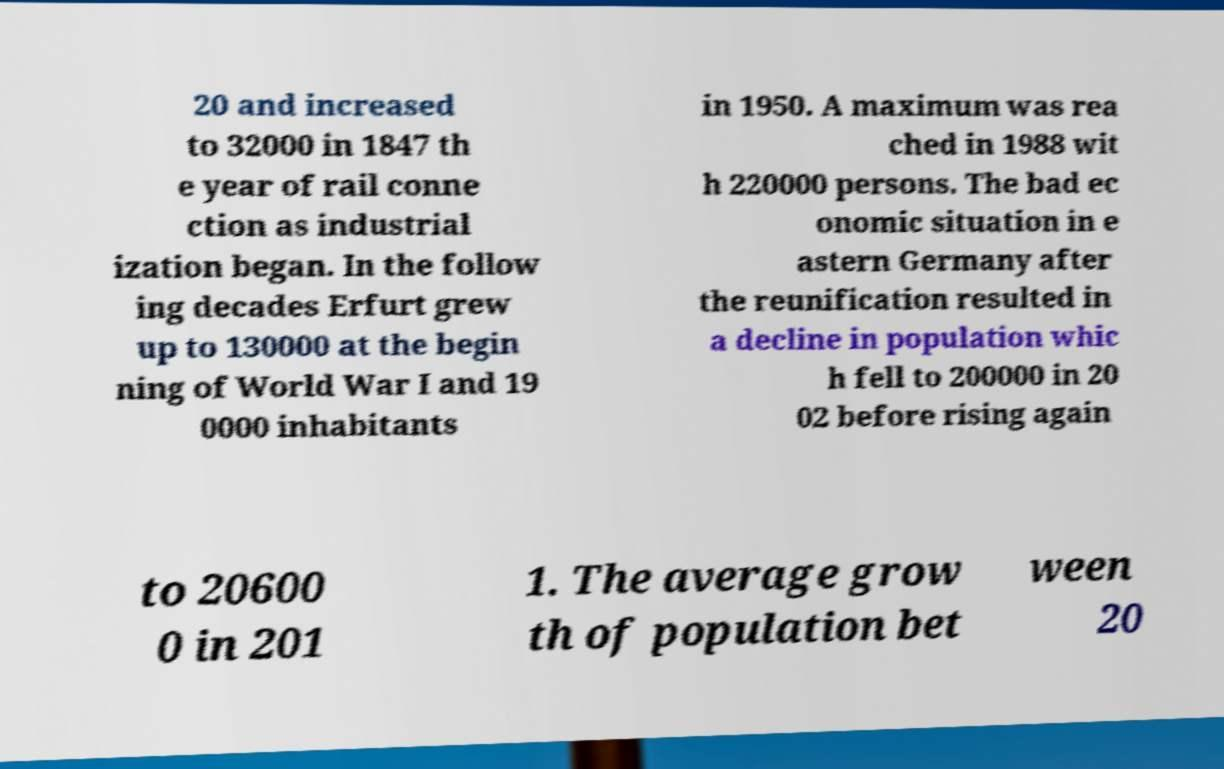Could you assist in decoding the text presented in this image and type it out clearly? 20 and increased to 32000 in 1847 th e year of rail conne ction as industrial ization began. In the follow ing decades Erfurt grew up to 130000 at the begin ning of World War I and 19 0000 inhabitants in 1950. A maximum was rea ched in 1988 wit h 220000 persons. The bad ec onomic situation in e astern Germany after the reunification resulted in a decline in population whic h fell to 200000 in 20 02 before rising again to 20600 0 in 201 1. The average grow th of population bet ween 20 